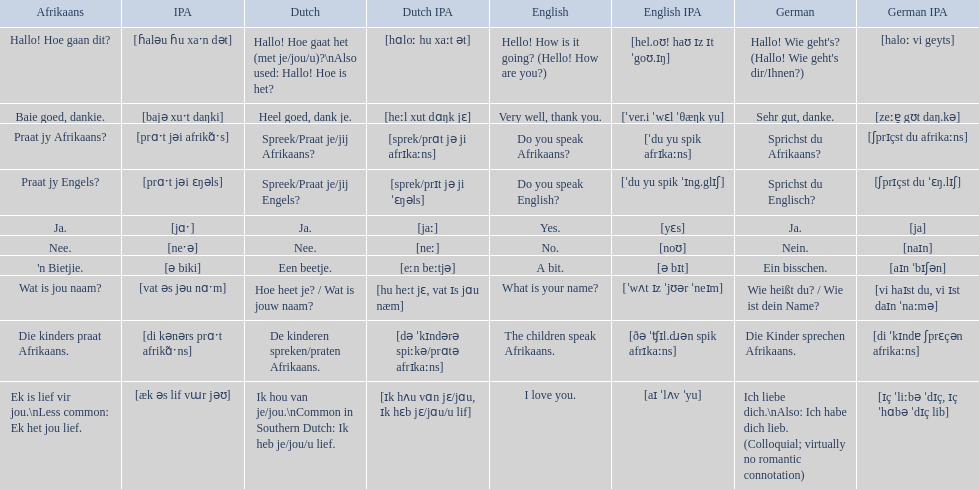How do you say do you speak english in german? Sprichst du Englisch?. What about do you speak afrikaanss? in afrikaans? Praat jy Afrikaans?. 